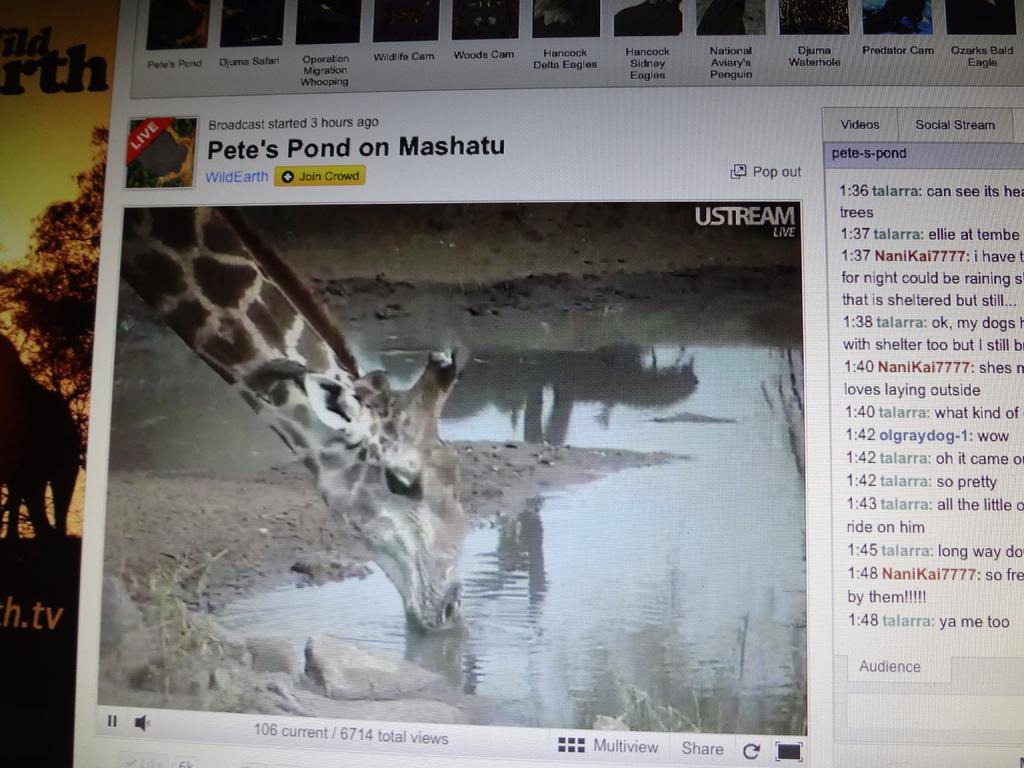Can you describe this image briefly? In this image I can see the screen short and I can also see an animal and something is written on the image. 